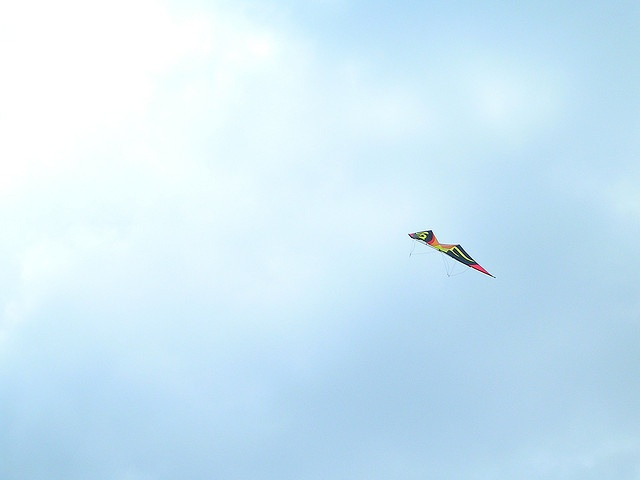Describe the objects in this image and their specific colors. I can see a kite in white, lightblue, black, and blue tones in this image. 